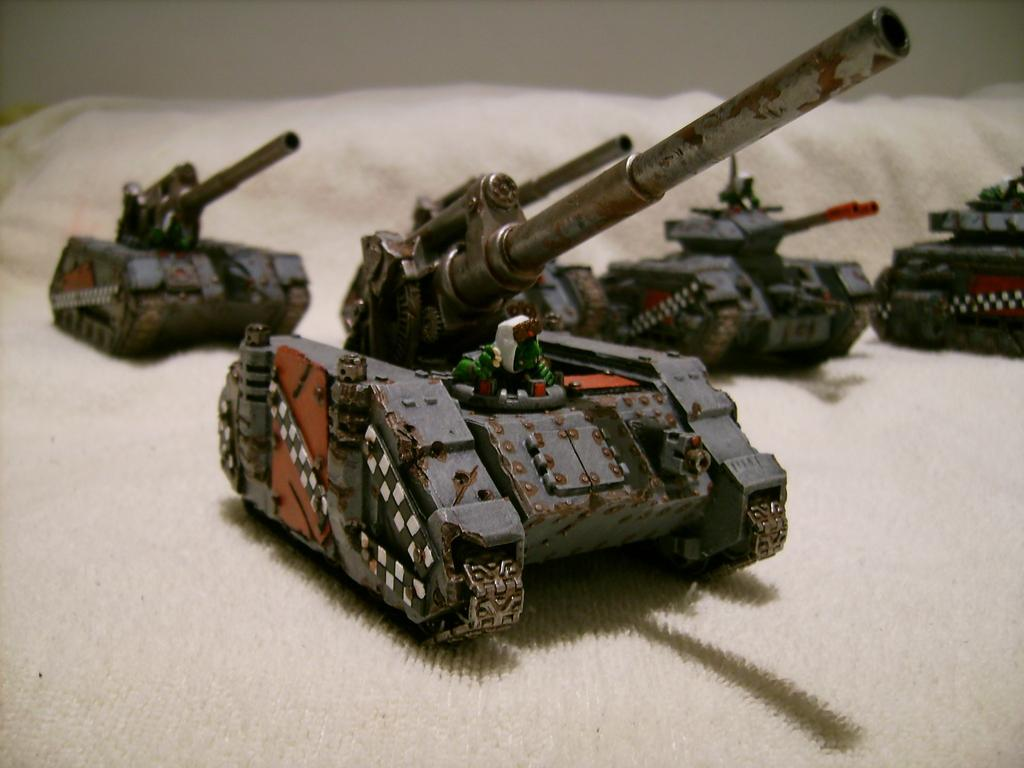What type of toys are present in the image? There are war tank toys in the image. What can be seen in the background of the image? There is a wall visible in the image. How does the pollution affect the war tank toys in the image? There is no mention of pollution in the image, so we cannot determine its effect on the war tank toys. 